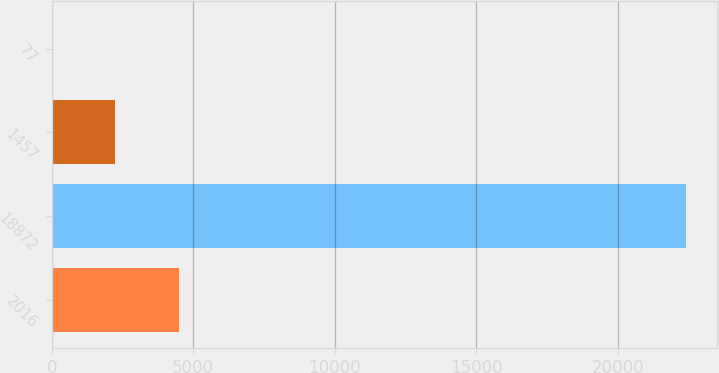<chart> <loc_0><loc_0><loc_500><loc_500><bar_chart><fcel>2016<fcel>18872<fcel>1457<fcel>77<nl><fcel>4482.56<fcel>22398<fcel>2243.13<fcel>3.7<nl></chart> 